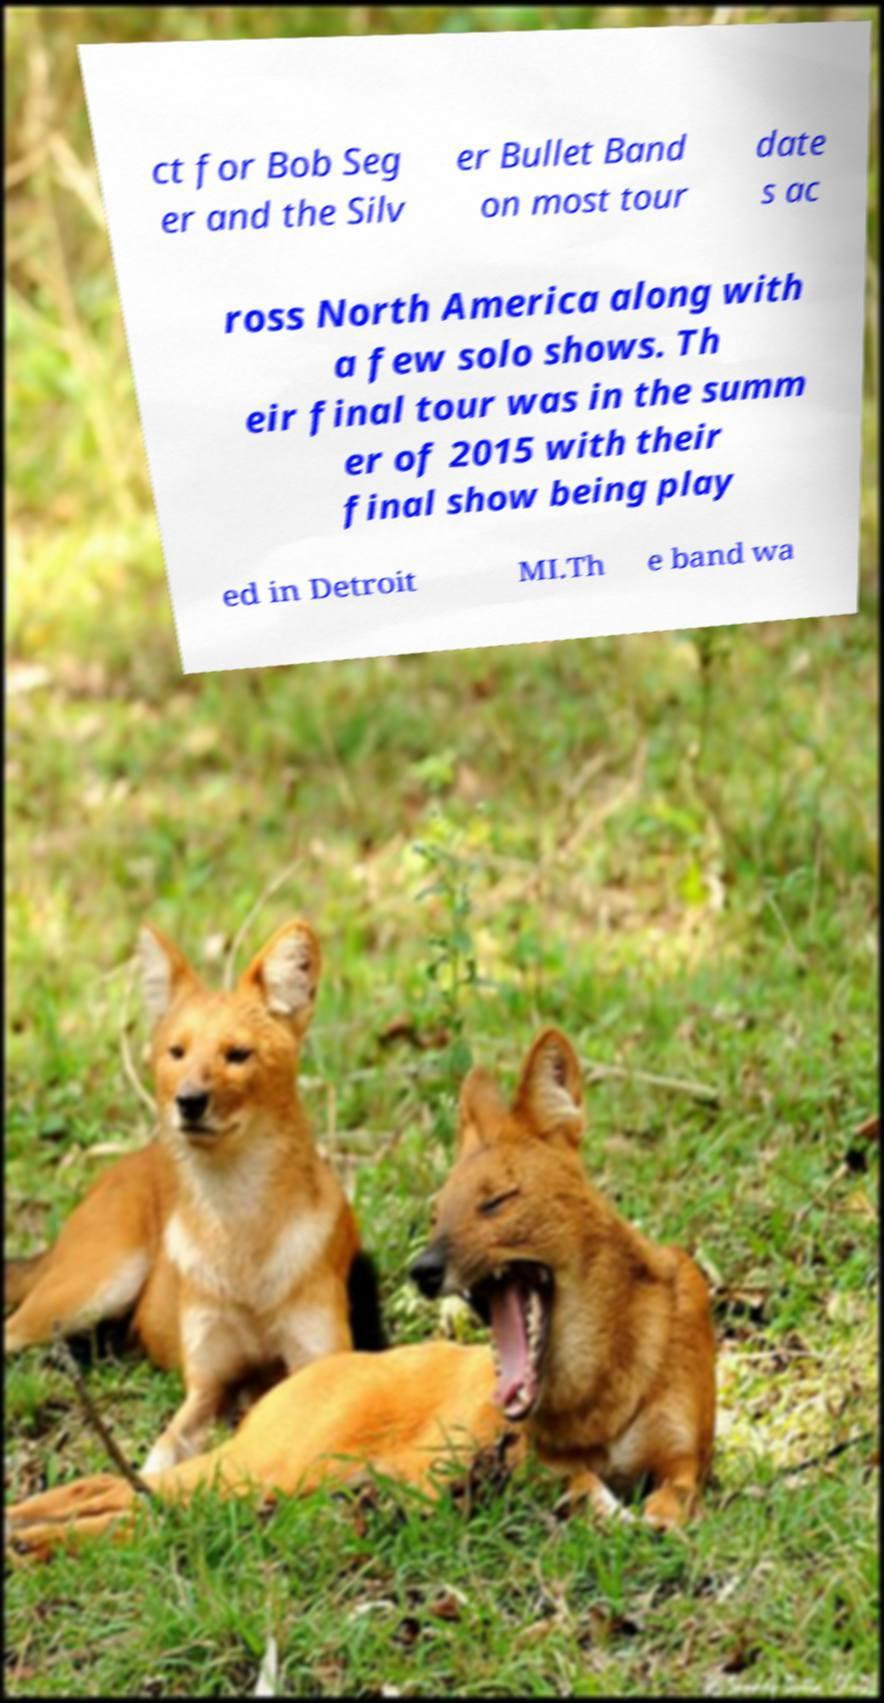Could you assist in decoding the text presented in this image and type it out clearly? ct for Bob Seg er and the Silv er Bullet Band on most tour date s ac ross North America along with a few solo shows. Th eir final tour was in the summ er of 2015 with their final show being play ed in Detroit MI.Th e band wa 